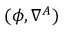<formula> <loc_0><loc_0><loc_500><loc_500>( \phi , \nabla ^ { A } )</formula> 